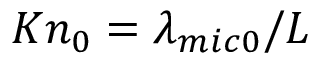<formula> <loc_0><loc_0><loc_500><loc_500>K { { n } _ { 0 } } = { { { \lambda } _ { m i c 0 } } } / { L }</formula> 